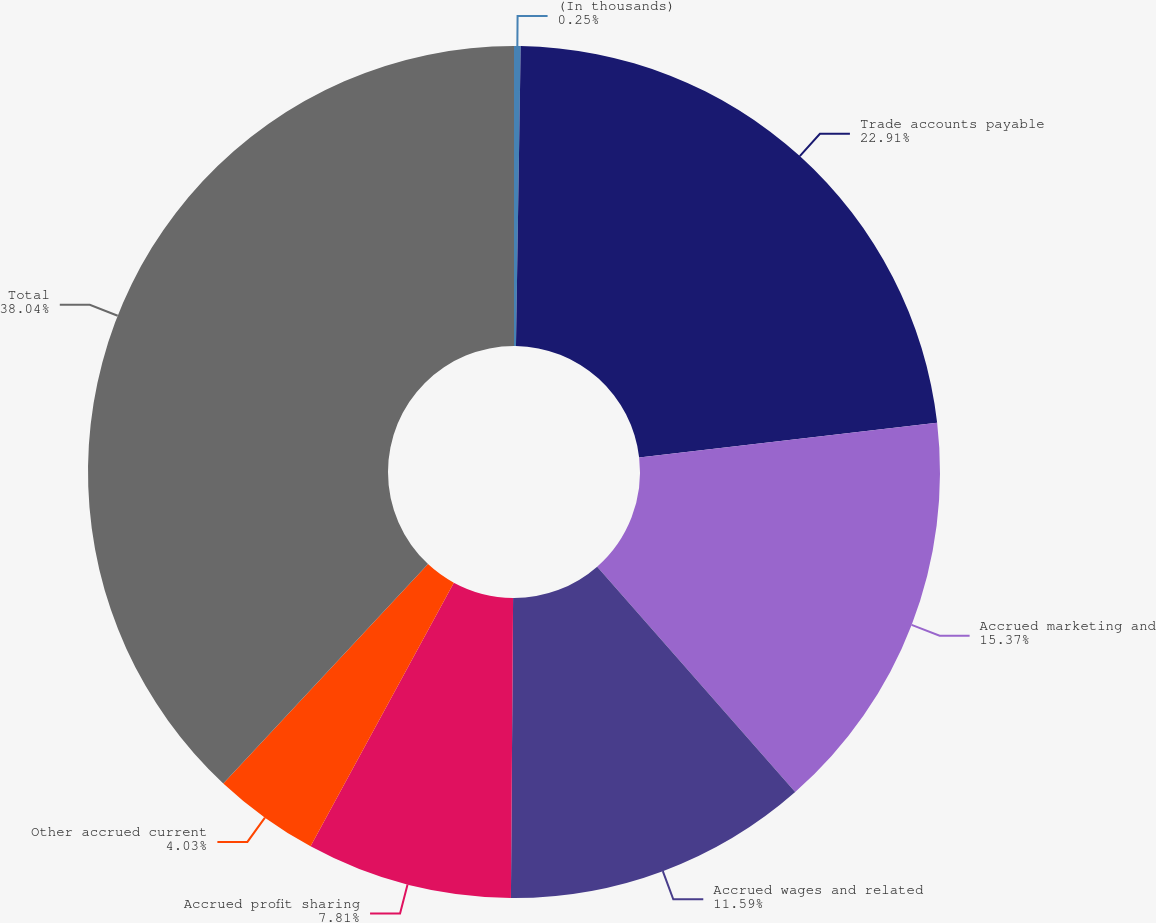Convert chart to OTSL. <chart><loc_0><loc_0><loc_500><loc_500><pie_chart><fcel>(In thousands)<fcel>Trade accounts payable<fcel>Accrued marketing and<fcel>Accrued wages and related<fcel>Accrued profit sharing<fcel>Other accrued current<fcel>Total<nl><fcel>0.25%<fcel>22.91%<fcel>15.37%<fcel>11.59%<fcel>7.81%<fcel>4.03%<fcel>38.05%<nl></chart> 